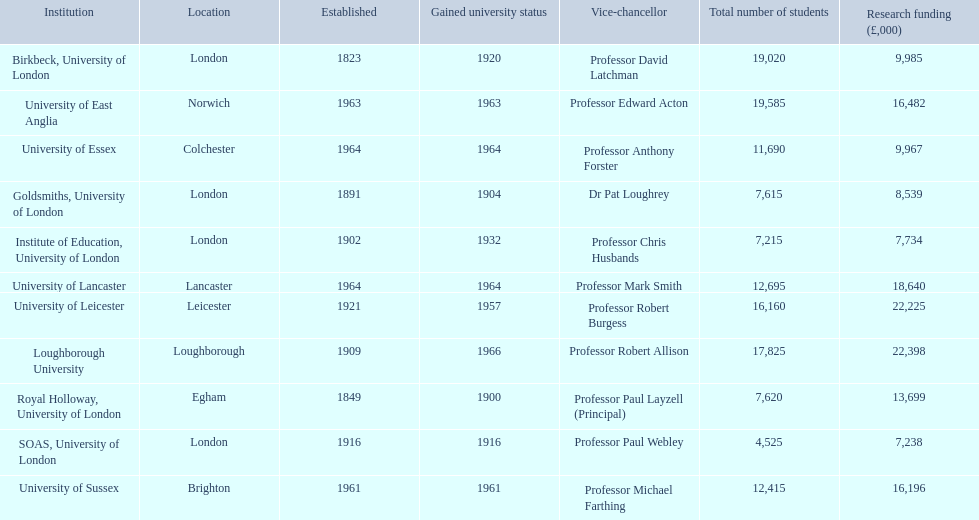What is the location of birkbeck, university of london? London. Which educational institution was founded in 1921? University of Leicester. Could you parse the entire table? {'header': ['Institution', 'Location', 'Established', 'Gained university status', 'Vice-chancellor', 'Total number of students', 'Research funding (£,000)'], 'rows': [['Birkbeck, University of London', 'London', '1823', '1920', 'Professor David Latchman', '19,020', '9,985'], ['University of East Anglia', 'Norwich', '1963', '1963', 'Professor Edward Acton', '19,585', '16,482'], ['University of Essex', 'Colchester', '1964', '1964', 'Professor Anthony Forster', '11,690', '9,967'], ['Goldsmiths, University of London', 'London', '1891', '1904', 'Dr Pat Loughrey', '7,615', '8,539'], ['Institute of Education, University of London', 'London', '1902', '1932', 'Professor Chris Husbands', '7,215', '7,734'], ['University of Lancaster', 'Lancaster', '1964', '1964', 'Professor Mark Smith', '12,695', '18,640'], ['University of Leicester', 'Leicester', '1921', '1957', 'Professor Robert Burgess', '16,160', '22,225'], ['Loughborough University', 'Loughborough', '1909', '1966', 'Professor Robert Allison', '17,825', '22,398'], ['Royal Holloway, University of London', 'Egham', '1849', '1900', 'Professor Paul Layzell (Principal)', '7,620', '13,699'], ['SOAS, University of London', 'London', '1916', '1916', 'Professor Paul Webley', '4,525', '7,238'], ['University of Sussex', 'Brighton', '1961', '1961', 'Professor Michael Farthing', '12,415', '16,196']]} Which establishment has recently been granted university status? Loughborough University. 